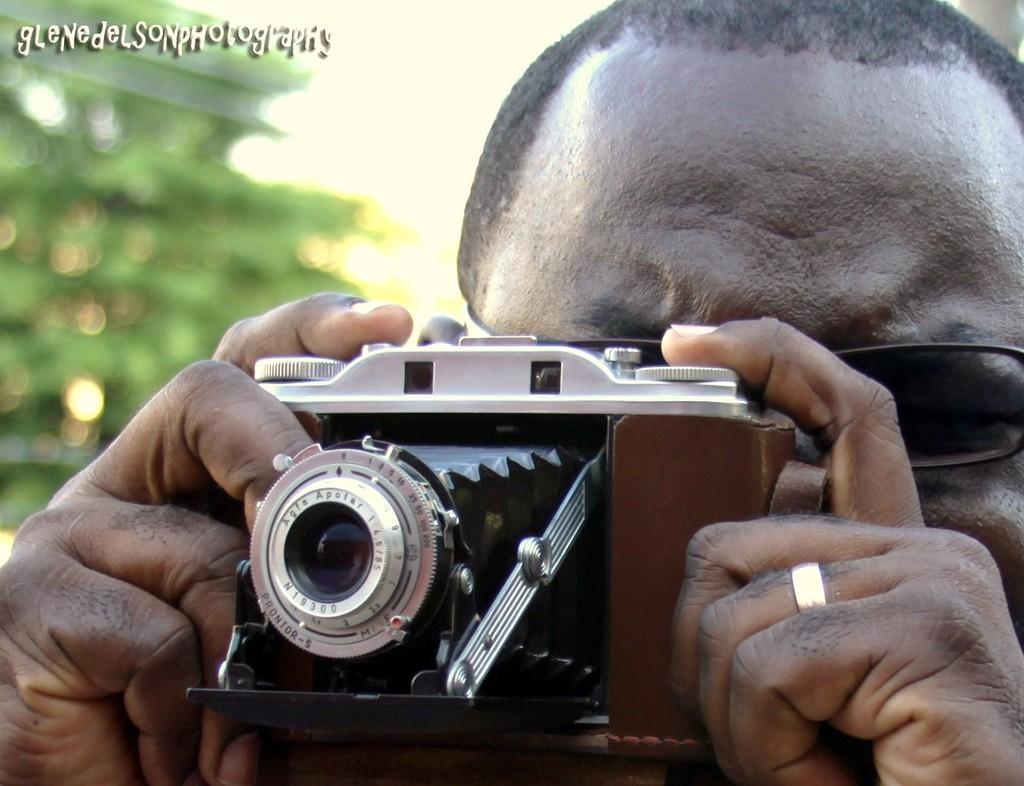Please provide a concise description of this image. In the image we can see there is a man who is carrying camera in his hand. 